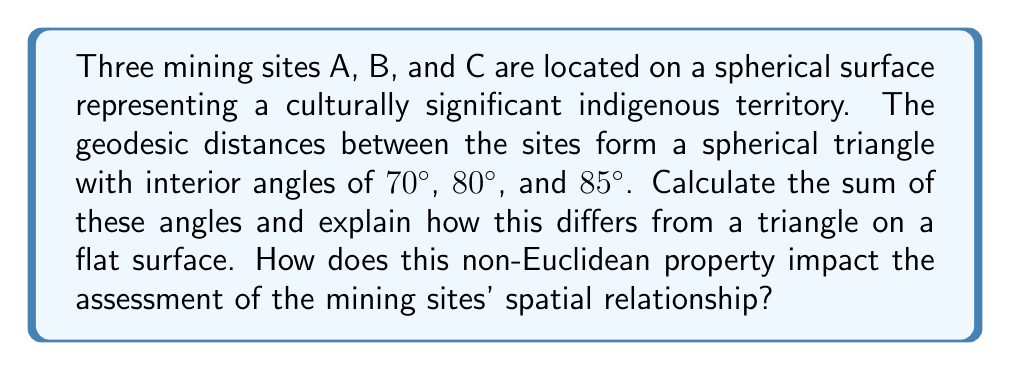Provide a solution to this math problem. To solve this problem, we need to understand the properties of spherical geometry, which is a type of non-Euclidean geometry.

Step 1: Recall the formula for the angle sum of a spherical triangle.
In spherical geometry, the sum of the interior angles of a triangle is always greater than 180°. The formula is:

$$ S = \alpha + \beta + \gamma - 180° $$

Where $S$ is the spherical excess, and $\alpha$, $\beta$, and $\gamma$ are the interior angles of the spherical triangle.

Step 2: Calculate the sum of the given angles.
$$ \text{Sum} = 70° + 80° + 85° = 235° $$

Step 3: Calculate the spherical excess.
$$ S = 235° - 180° = 55° $$

Step 4: Compare to a flat (Euclidean) surface.
On a flat surface, the sum of the angles in a triangle is always 180°. The difference of 55° is due to the curvature of the spherical surface.

Step 5: Interpret the result in the context of mining site assessment.
This non-Euclidean property means that the spatial relationships between the mining sites are different from what they would be on a flat map. The excess angle indicates the amount of curvature encompassed by the triangle, which affects distance calculations, area measurements, and navigational considerations between the sites.

For the indigenous affairs representative, this understanding is crucial for:
1. Accurately assessing the impact area of the mining projects
2. Ensuring proper demarcation of indigenous territories
3. Planning conservation efforts around the mining sites
4. Calculating fair compensation based on accurate land measurements
Answer: 235°; 55° more than a flat triangle due to spherical geometry, impacting spatial assessments. 